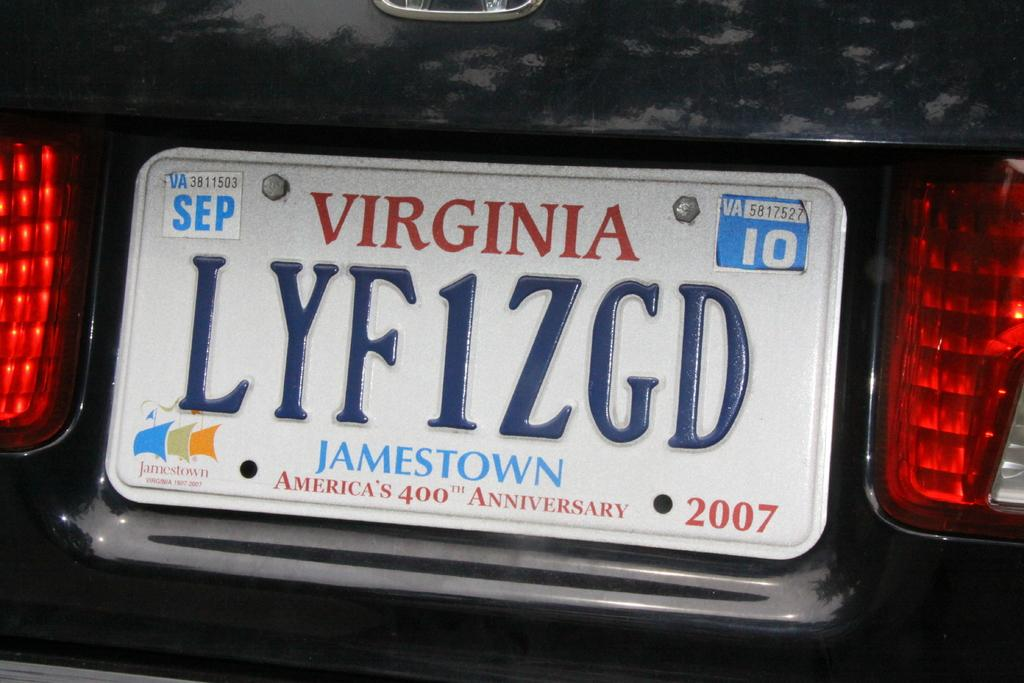<image>
Offer a succinct explanation of the picture presented. a license plate that has the word Virginia on it 